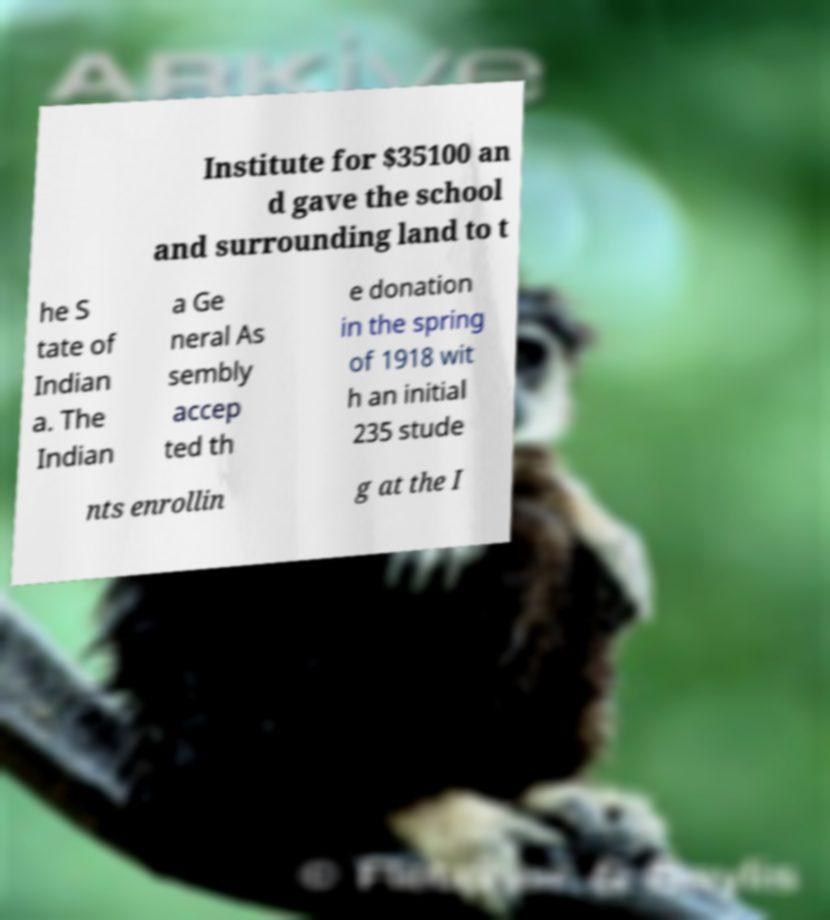Please read and relay the text visible in this image. What does it say? Institute for $35100 an d gave the school and surrounding land to t he S tate of Indian a. The Indian a Ge neral As sembly accep ted th e donation in the spring of 1918 wit h an initial 235 stude nts enrollin g at the I 